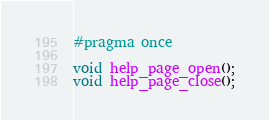Convert code to text. <code><loc_0><loc_0><loc_500><loc_500><_C_>#pragma once

void help_page_open();
void help_page_close();
</code> 